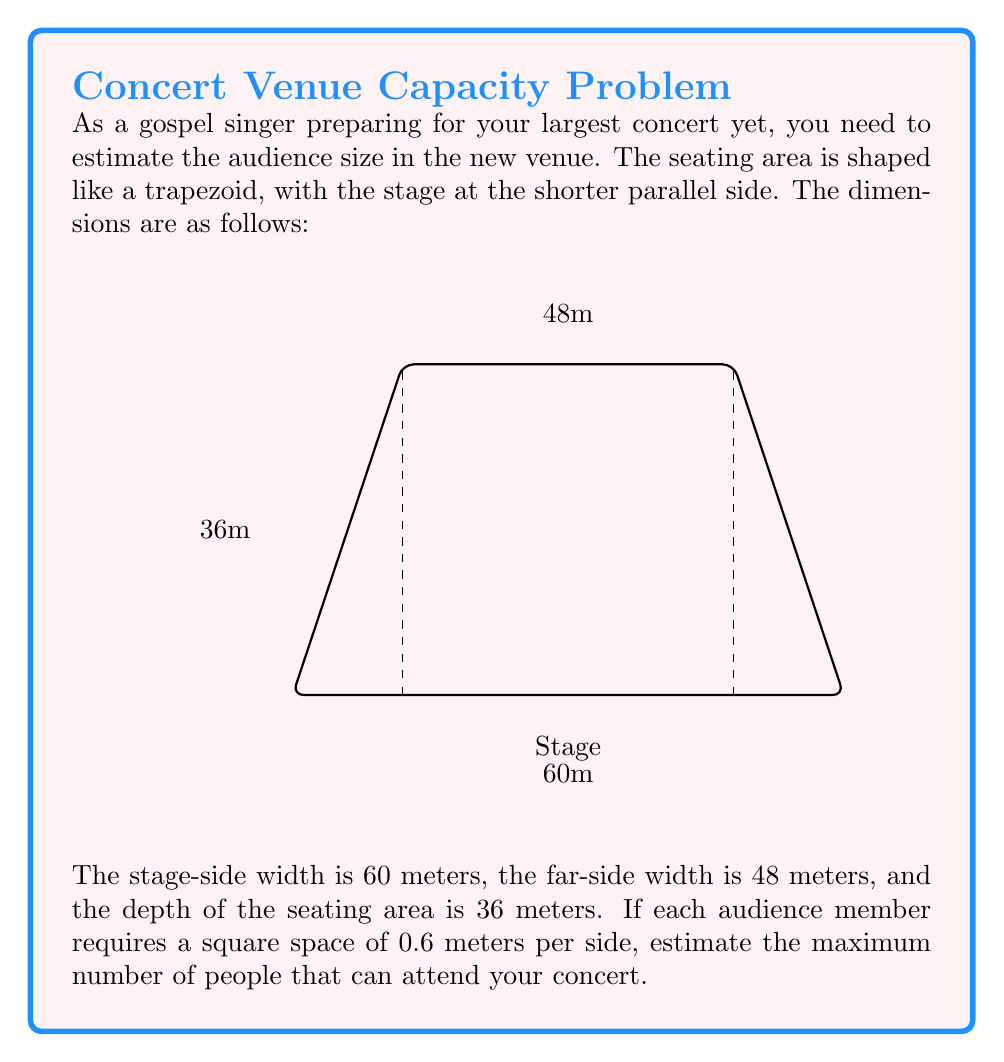Could you help me with this problem? Let's approach this step-by-step:

1) First, we need to calculate the area of the trapezoid-shaped seating area. The formula for the area of a trapezoid is:

   $$A = \frac{1}{2}(b_1 + b_2)h$$

   where $b_1$ and $b_2$ are the parallel sides and $h$ is the height.

2) Plugging in our values:
   $$A = \frac{1}{2}(60 + 48) \times 36 = 54 \times 36 = 1,944 \text{ m}^2$$

3) Now, we need to determine how much space each person occupies. Given that each person requires a square of 0.6m per side, the area per person is:

   $$0.6 \text{ m} \times 0.6 \text{ m} = 0.36 \text{ m}^2$$

4) To find the number of people that can fit, we divide the total area by the area per person:

   $$\text{Number of people} = \frac{\text{Total Area}}{\text{Area per person}} = \frac{1,944 \text{ m}^2}{0.36 \text{ m}^2} = 5,400$$

5) However, this assumes perfect packing without any aisles or spaces. In reality, we should account for some inefficiency. Let's assume 90% efficiency:

   $$5,400 \times 0.9 = 4,860$$

6) Rounding down to be conservative:

   $$4,860 \approx 4,800 \text{ people}$$
Answer: 4,800 people 